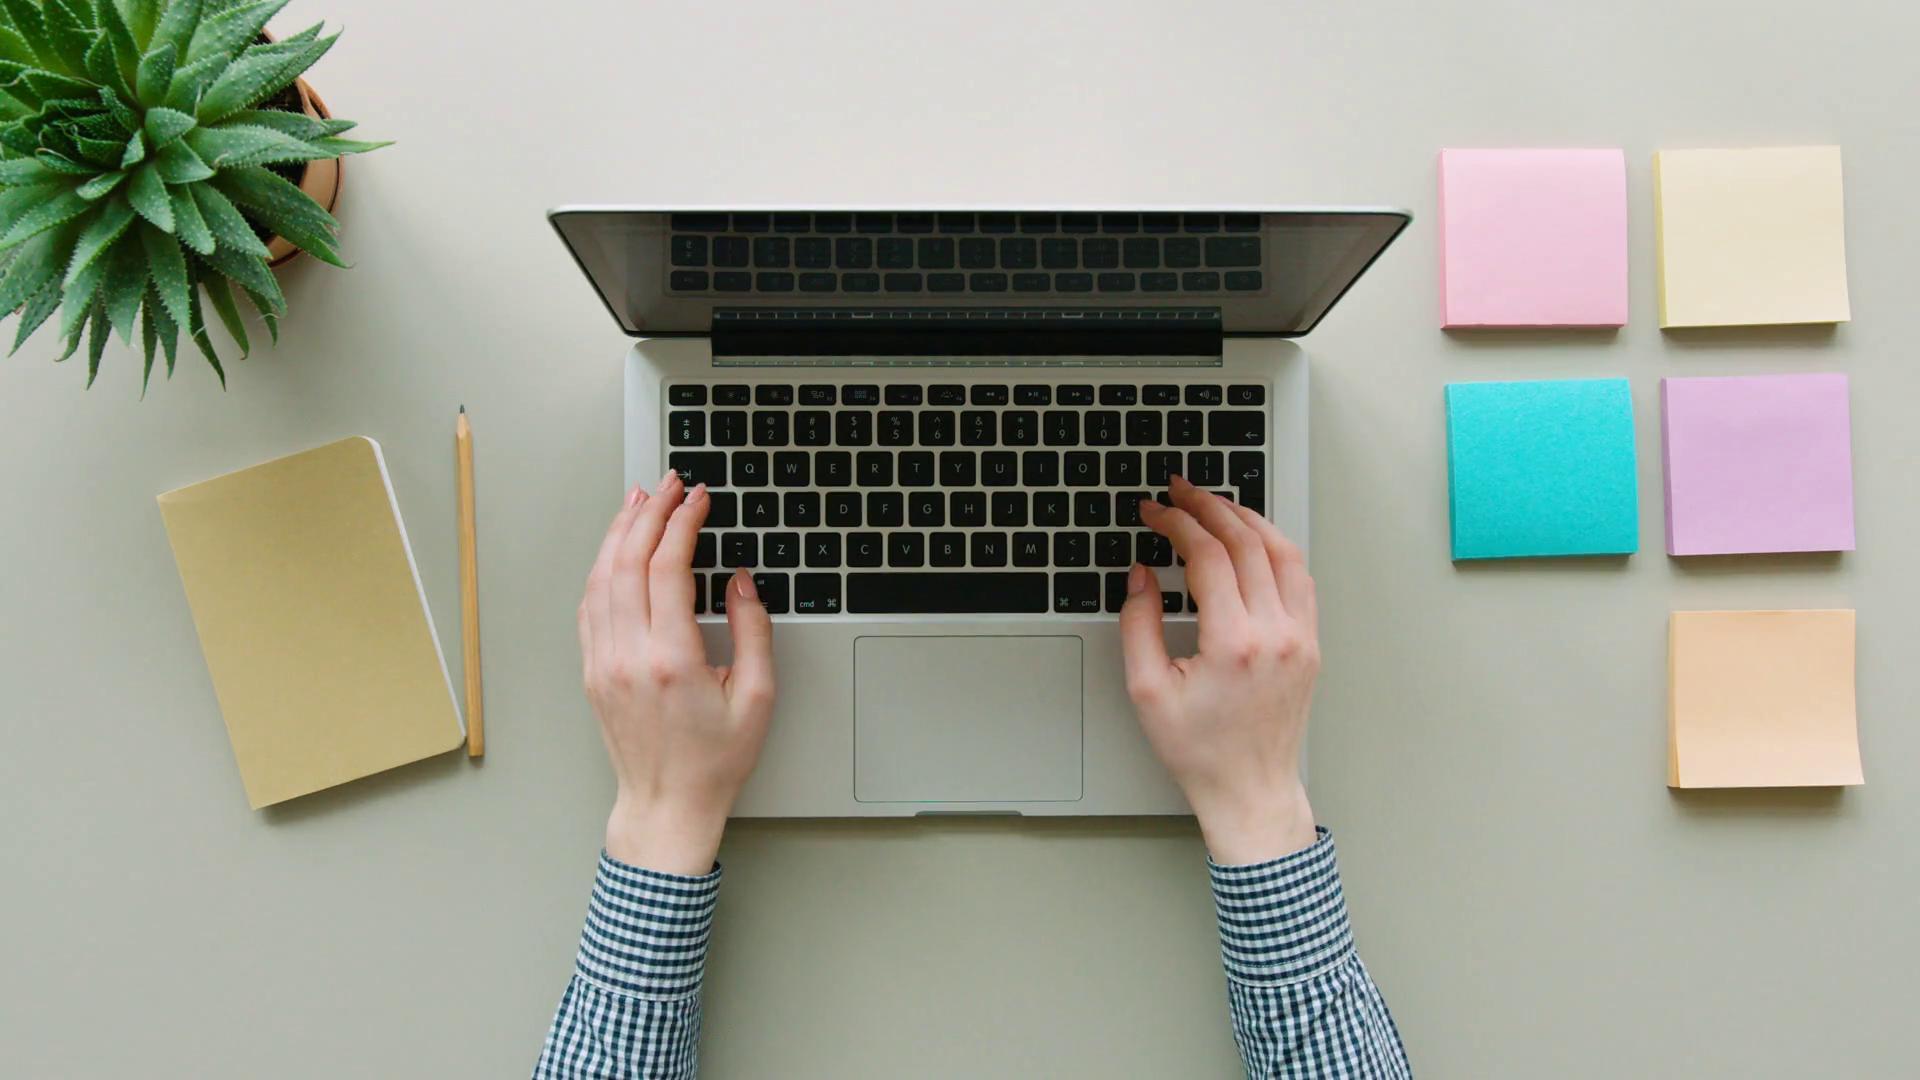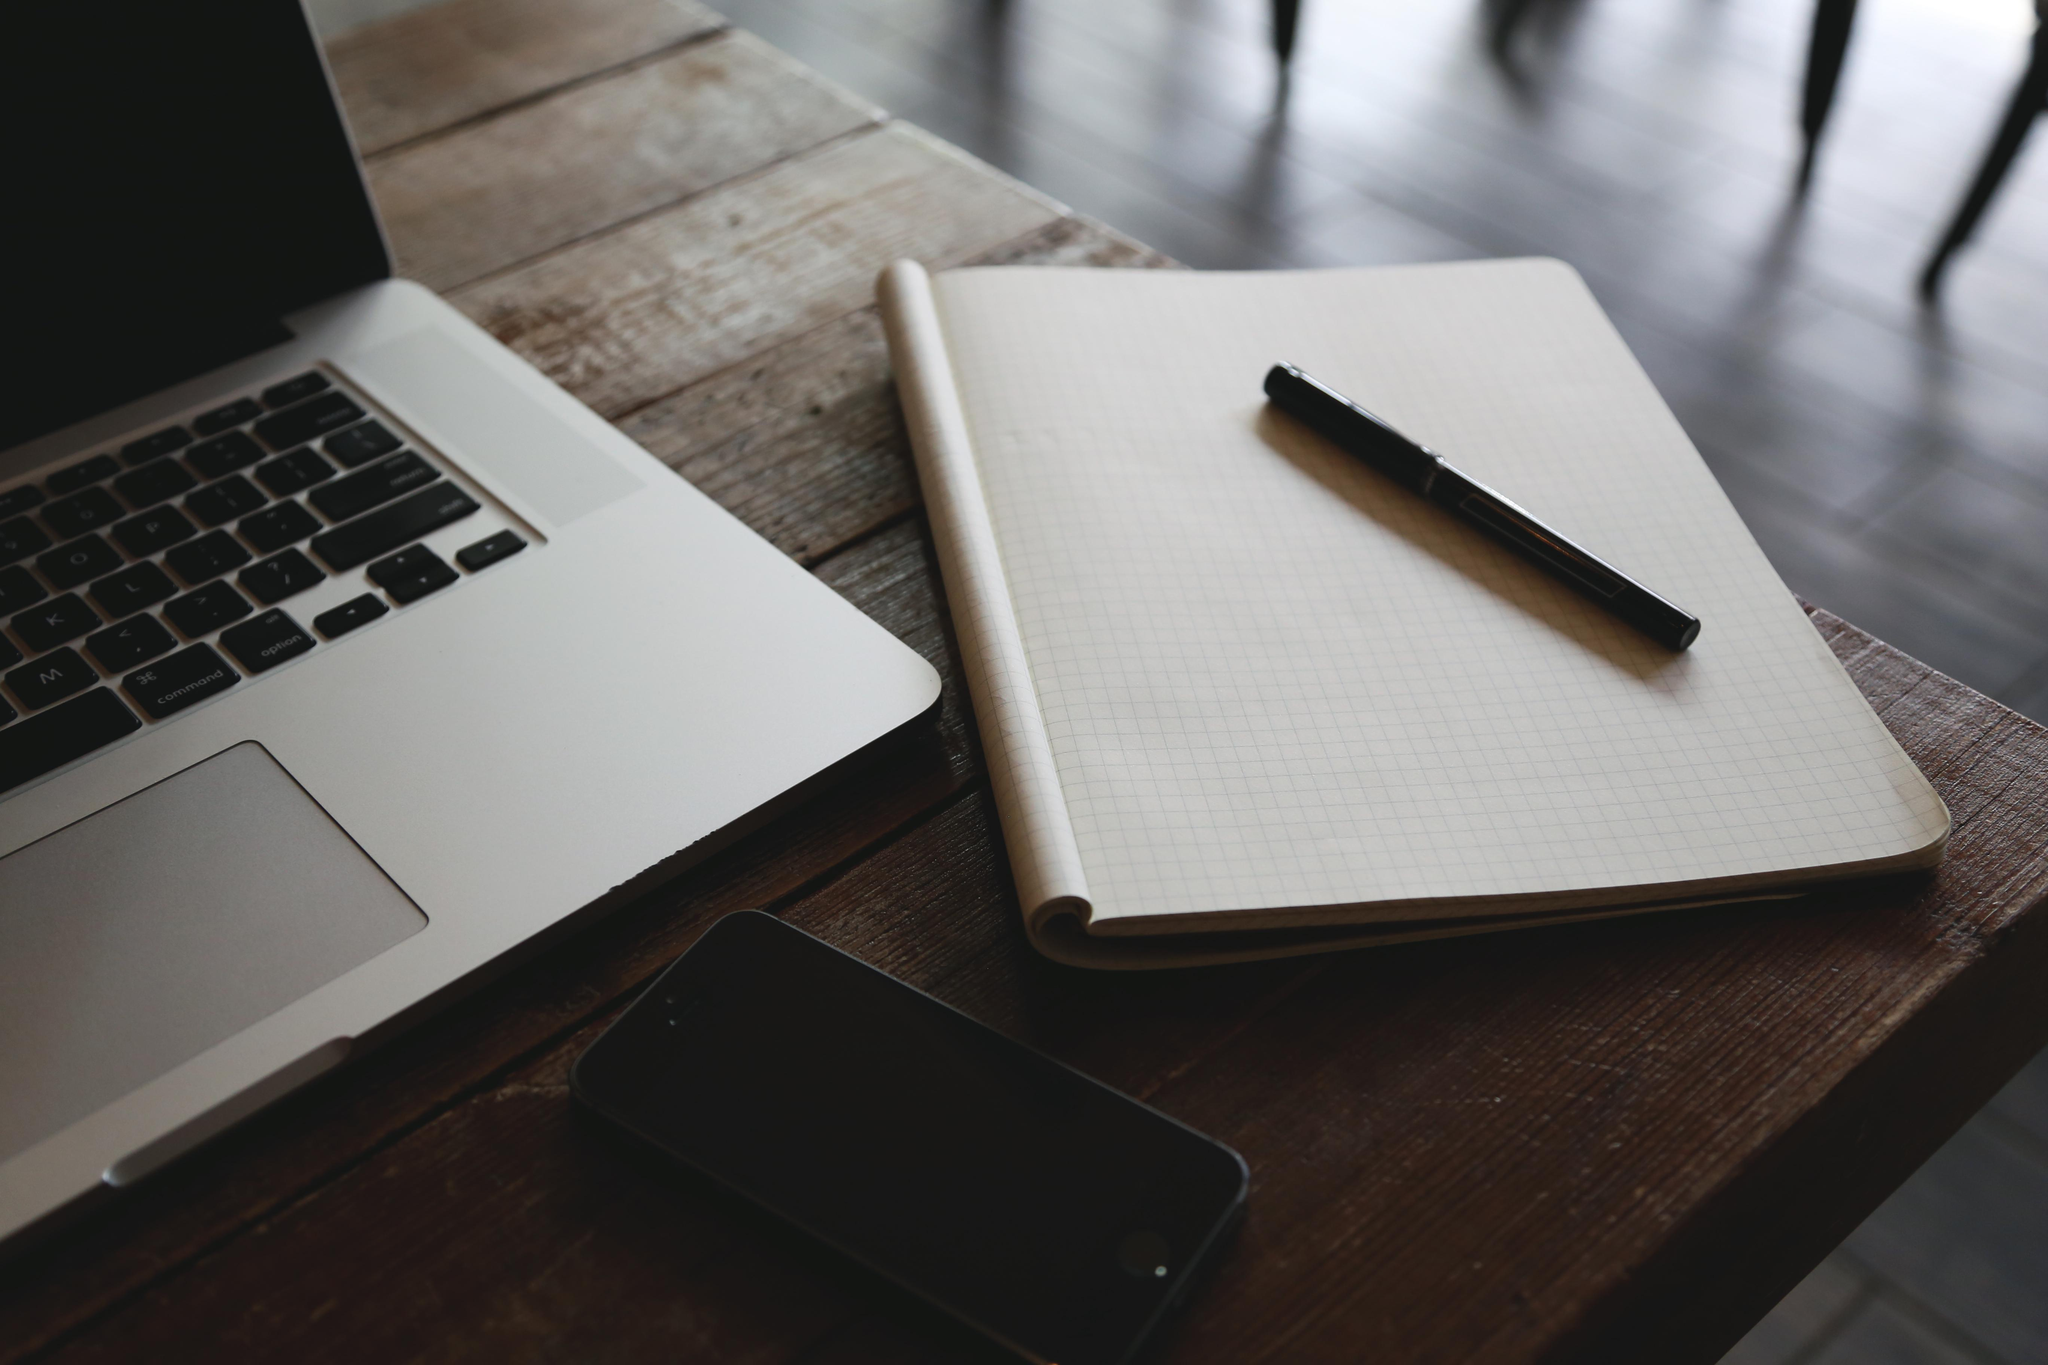The first image is the image on the left, the second image is the image on the right. Examine the images to the left and right. Is the description "Each image shows at least one hand on the keyboard of a laptop with its open screen facing leftward." accurate? Answer yes or no. No. The first image is the image on the left, the second image is the image on the right. For the images shown, is this caption "A pen is on a paper near a laptop in at least one of the images." true? Answer yes or no. Yes. 